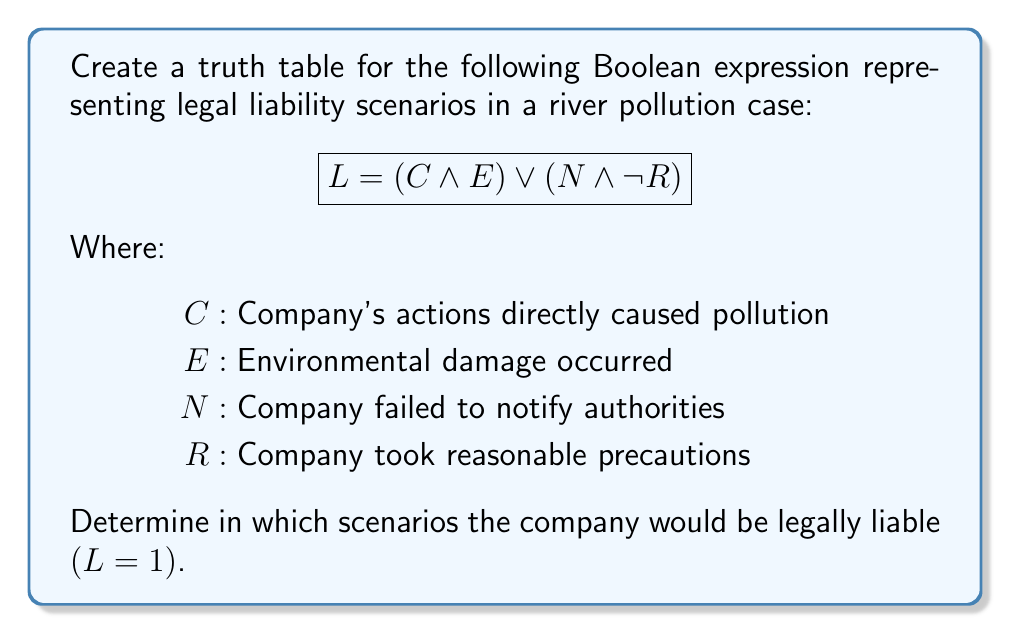Give your solution to this math problem. To create a truth table for this Boolean expression, we need to follow these steps:

1. Identify the variables: $C$, $E$, $N$, and $R$
2. List all possible combinations of these variables (16 in total)
3. Evaluate the subexpressions: $(C \land E)$ and $(N \land \neg R)$
4. Combine the subexpressions using OR to get the final result for $L$

Let's create the truth table:

$$
\begin{array}{|c|c|c|c|c|c|c|}
\hline
C & E & N & R & (C \land E) & (N \land \neg R) & L \\
\hline
0 & 0 & 0 & 0 & 0 & 0 & 0 \\
0 & 0 & 0 & 1 & 0 & 0 & 0 \\
0 & 0 & 1 & 0 & 0 & 1 & 1 \\
0 & 0 & 1 & 1 & 0 & 0 & 0 \\
0 & 1 & 0 & 0 & 0 & 0 & 0 \\
0 & 1 & 0 & 1 & 0 & 0 & 0 \\
0 & 1 & 1 & 0 & 0 & 1 & 1 \\
0 & 1 & 1 & 1 & 0 & 0 & 0 \\
1 & 0 & 0 & 0 & 0 & 0 & 0 \\
1 & 0 & 0 & 1 & 0 & 0 & 0 \\
1 & 0 & 1 & 0 & 0 & 1 & 1 \\
1 & 0 & 1 & 1 & 0 & 0 & 0 \\
1 & 1 & 0 & 0 & 1 & 0 & 1 \\
1 & 1 & 0 & 1 & 1 & 0 & 1 \\
1 & 1 & 1 & 0 & 1 & 1 & 1 \\
1 & 1 & 1 & 1 & 1 & 0 & 1 \\
\hline
\end{array}
$$

The company is legally liable $(L = 1)$ in 6 out of 16 scenarios:

1. When $C = 0$, $E = 0$, $N = 1$, $R = 0$
2. When $C = 0$, $E = 1$, $N = 1$, $R = 0$
3. When $C = 1$, $E = 0$, $N = 1$, $R = 0$
4. When $C = 1$, $E = 1$, $N = 0$, $R = 0$
5. When $C = 1$, $E = 1$, $N = 0$, $R = 1$
6. When $C = 1$, $E = 1$, $N = 1$, $R = 0$
7. When $C = 1$, $E = 1$, $N = 1$, $R = 1$

These scenarios represent cases where either the company's actions directly caused pollution and environmental damage occurred, or the company failed to notify authorities and did not take reasonable precautions.
Answer: $L = 1$ in 6 scenarios: $(0,0,1,0)$, $(0,1,1,0)$, $(1,0,1,0)$, $(1,1,0,0)$, $(1,1,0,1)$, $(1,1,1,0)$, $(1,1,1,1)$ 